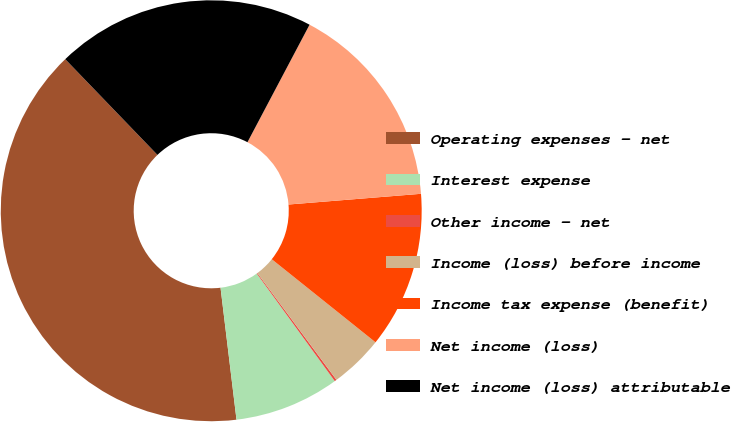Convert chart. <chart><loc_0><loc_0><loc_500><loc_500><pie_chart><fcel>Operating expenses - net<fcel>Interest expense<fcel>Other income - net<fcel>Income (loss) before income<fcel>Income tax expense (benefit)<fcel>Net income (loss)<fcel>Net income (loss) attributable<nl><fcel>39.72%<fcel>8.07%<fcel>0.16%<fcel>4.11%<fcel>12.03%<fcel>15.98%<fcel>19.94%<nl></chart> 